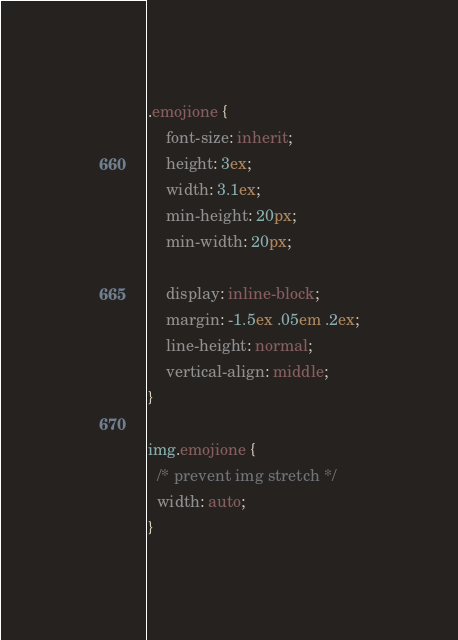<code> <loc_0><loc_0><loc_500><loc_500><_CSS_>.emojione {
    font-size: inherit;
    height: 3ex;
    width: 3.1ex;
    min-height: 20px;
    min-width: 20px;
	
    display: inline-block;
    margin: -1.5ex .05em .2ex;
    line-height: normal;
    vertical-align: middle;
}

img.emojione {
  /* prevent img stretch */
  width: auto;
}</code> 